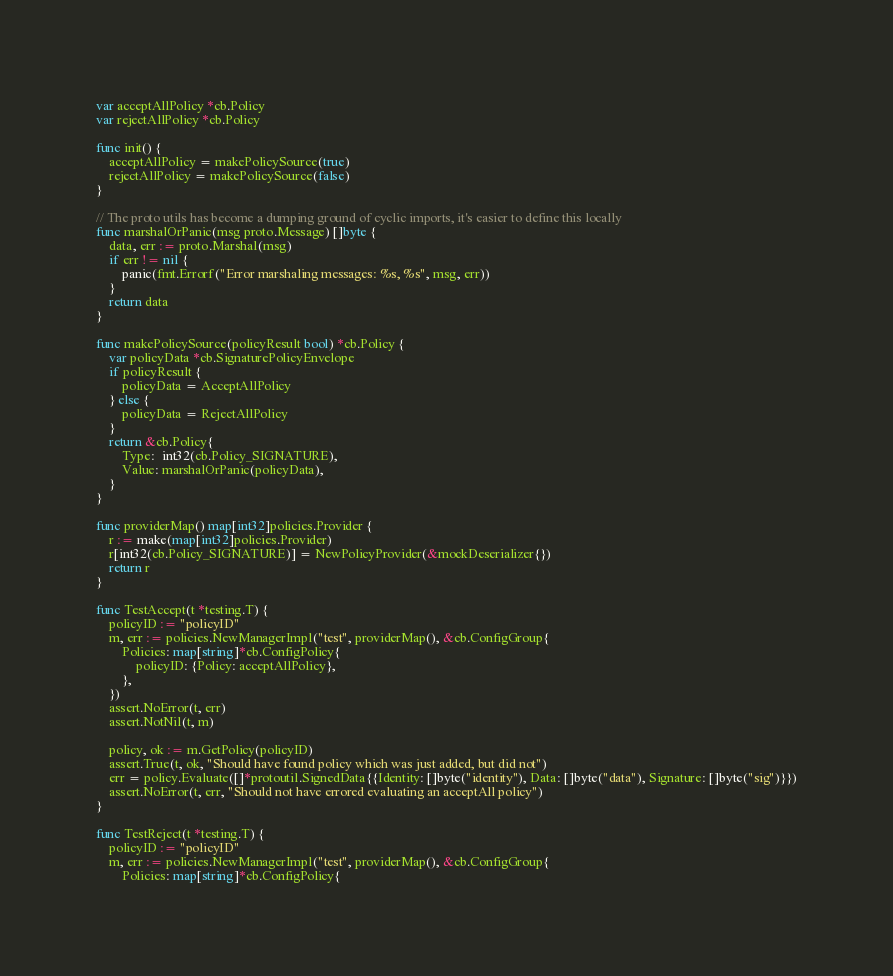<code> <loc_0><loc_0><loc_500><loc_500><_Go_>var acceptAllPolicy *cb.Policy
var rejectAllPolicy *cb.Policy

func init() {
	acceptAllPolicy = makePolicySource(true)
	rejectAllPolicy = makePolicySource(false)
}

// The proto utils has become a dumping ground of cyclic imports, it's easier to define this locally
func marshalOrPanic(msg proto.Message) []byte {
	data, err := proto.Marshal(msg)
	if err != nil {
		panic(fmt.Errorf("Error marshaling messages: %s, %s", msg, err))
	}
	return data
}

func makePolicySource(policyResult bool) *cb.Policy {
	var policyData *cb.SignaturePolicyEnvelope
	if policyResult {
		policyData = AcceptAllPolicy
	} else {
		policyData = RejectAllPolicy
	}
	return &cb.Policy{
		Type:  int32(cb.Policy_SIGNATURE),
		Value: marshalOrPanic(policyData),
	}
}

func providerMap() map[int32]policies.Provider {
	r := make(map[int32]policies.Provider)
	r[int32(cb.Policy_SIGNATURE)] = NewPolicyProvider(&mockDeserializer{})
	return r
}

func TestAccept(t *testing.T) {
	policyID := "policyID"
	m, err := policies.NewManagerImpl("test", providerMap(), &cb.ConfigGroup{
		Policies: map[string]*cb.ConfigPolicy{
			policyID: {Policy: acceptAllPolicy},
		},
	})
	assert.NoError(t, err)
	assert.NotNil(t, m)

	policy, ok := m.GetPolicy(policyID)
	assert.True(t, ok, "Should have found policy which was just added, but did not")
	err = policy.Evaluate([]*protoutil.SignedData{{Identity: []byte("identity"), Data: []byte("data"), Signature: []byte("sig")}})
	assert.NoError(t, err, "Should not have errored evaluating an acceptAll policy")
}

func TestReject(t *testing.T) {
	policyID := "policyID"
	m, err := policies.NewManagerImpl("test", providerMap(), &cb.ConfigGroup{
		Policies: map[string]*cb.ConfigPolicy{</code> 